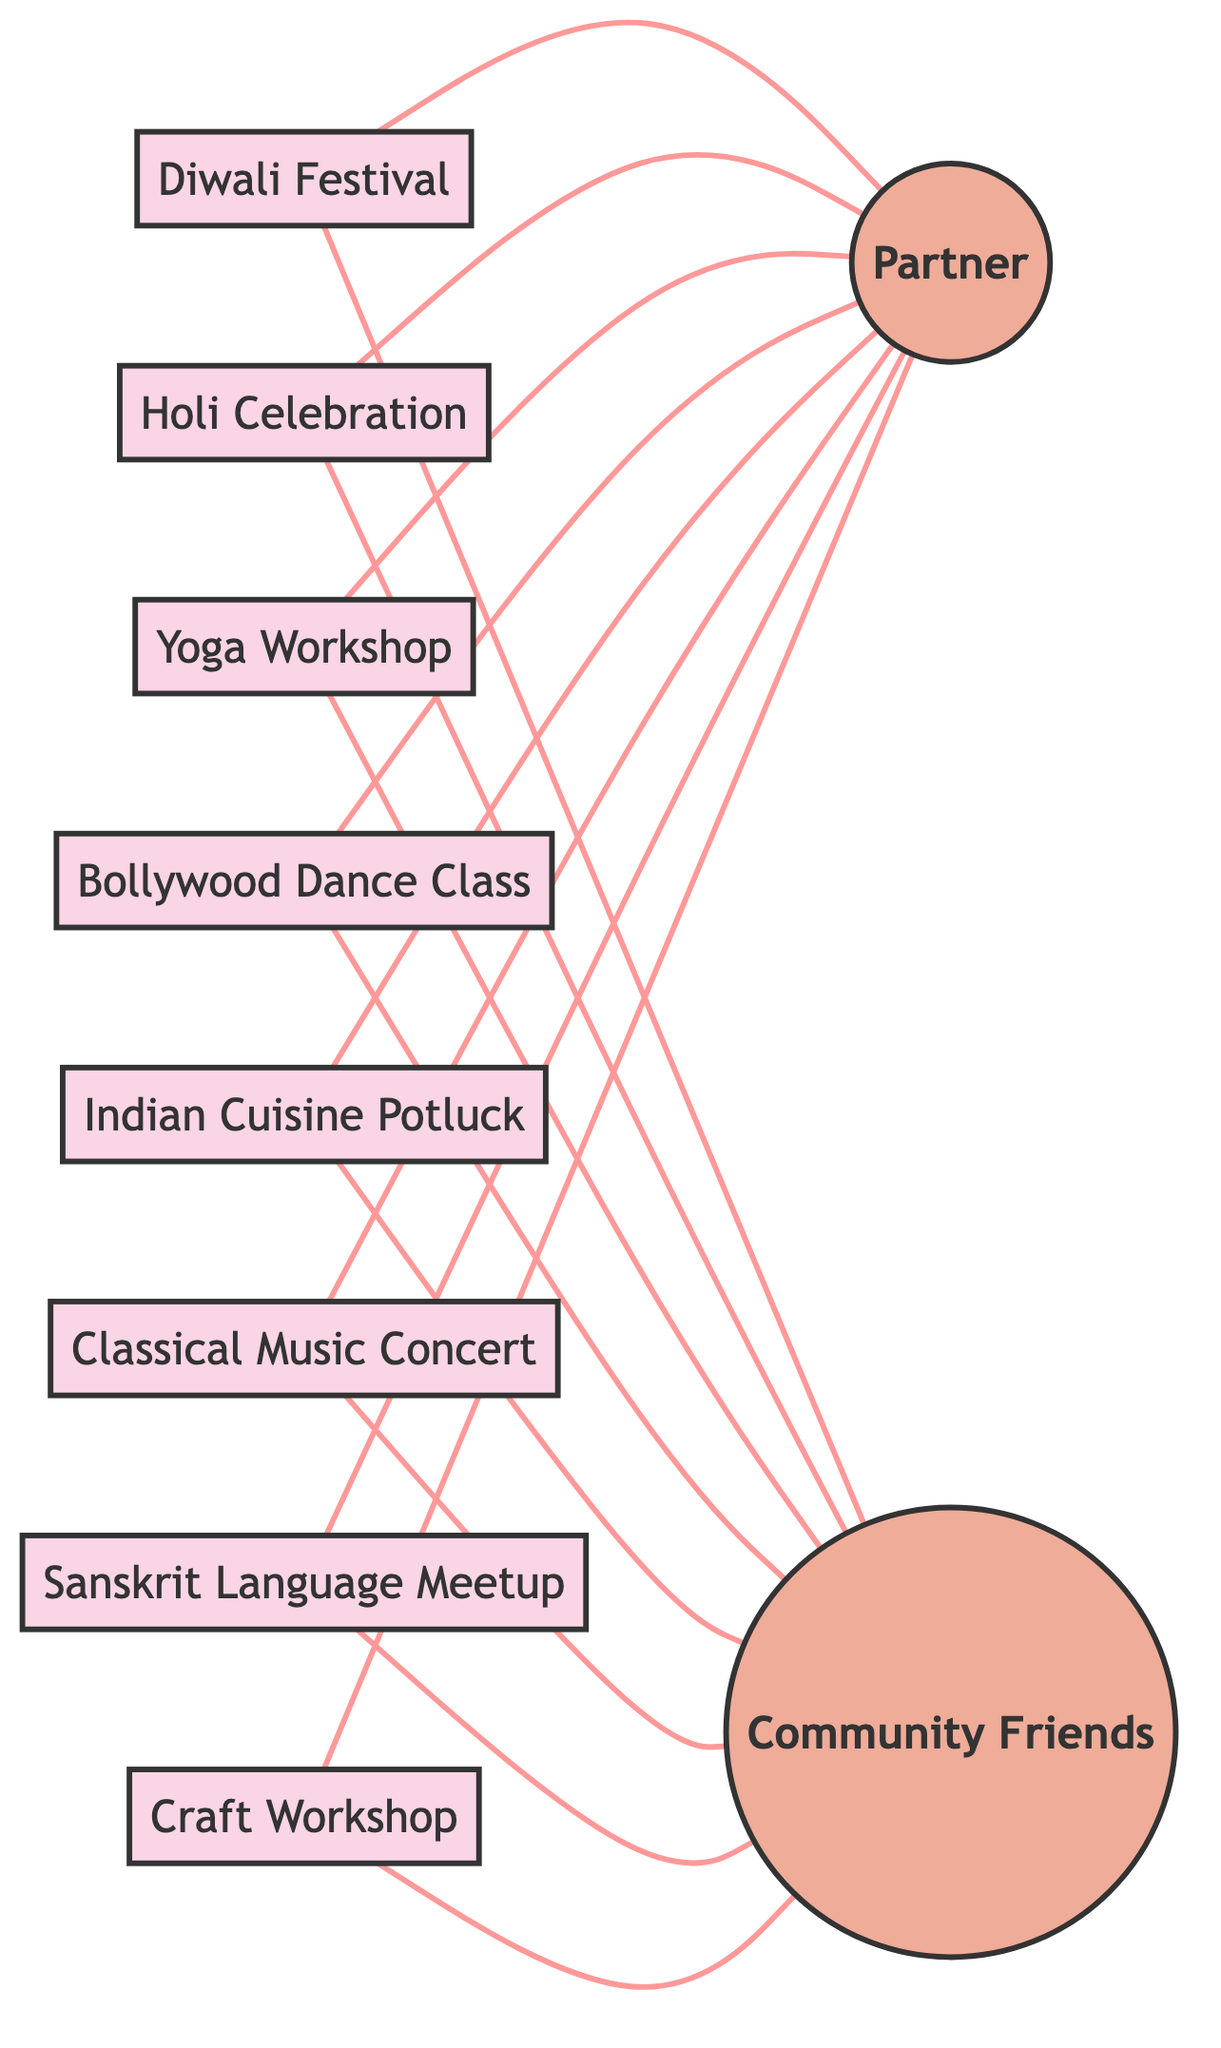What are the total number of nodes in the diagram? The nodes represent events and people in the graph. By counting, we find there are 10 distinct nodes: 8 events and 2 people (Partner and Community Friends).
Answer: 10 Which event is directly connected to the partner? The partner node is connected by edges to every event node. Therefore, any event that shows a direct link to the partner is connected. Identifying one of these events can suffice for the answer. The Diwali Festival is one such example.
Answer: Diwali Festival How many edges connect the events to the community friends? Each event node is connected to the Community Friends node, making it 8 connections (one for each event).
Answer: 8 Which two cultural events have the most direct connections to people? Each cultural event is connected to both the Partner and Community Friends nodes, giving each event 2 connections. Therefore, all events are equally connected to people.
Answer: All events Is there a cultural event that is only connected to the partner? By observing the relationships represented in the diagram, we see that every event is connected to both the Partner and Community Friends. Thus, no event is connected only to the Partner.
Answer: No How many cultural events are represented in the diagram? The diagram shows 8 different cultural events listed in the nodes section. Counting these nodes gives us the answer directly.
Answer: 8 Which event connects to both the Partner and Community Friends? Every event is connected to both nodes, so any event chosen will fulfill this requirement. For example, the Indian Cuisine Potluck connects to both.
Answer: Indian Cuisine Potluck What type of relationships exist between the Partner and Community Friends? The relationship is undirected, meaning that the connection exists from both directions—Partner connects to Community Friends and vice versa.
Answer: Undirected 